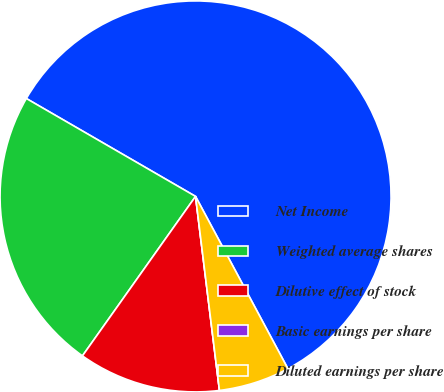Convert chart. <chart><loc_0><loc_0><loc_500><loc_500><pie_chart><fcel>Net Income<fcel>Weighted average shares<fcel>Dilutive effect of stock<fcel>Basic earnings per share<fcel>Diluted earnings per share<nl><fcel>58.82%<fcel>23.53%<fcel>11.77%<fcel>0.0%<fcel>5.88%<nl></chart> 